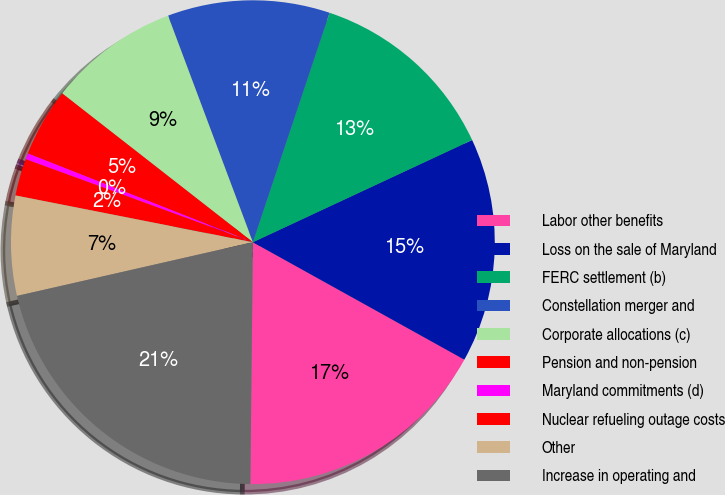<chart> <loc_0><loc_0><loc_500><loc_500><pie_chart><fcel>Labor other benefits<fcel>Loss on the sale of Maryland<fcel>FERC settlement (b)<fcel>Constellation merger and<fcel>Corporate allocations (c)<fcel>Pension and non-pension<fcel>Maryland commitments (d)<fcel>Nuclear refueling outage costs<fcel>Other<fcel>Increase in operating and<nl><fcel>17.1%<fcel>15.01%<fcel>12.92%<fcel>10.84%<fcel>8.75%<fcel>4.57%<fcel>0.4%<fcel>2.48%<fcel>6.66%<fcel>21.27%<nl></chart> 